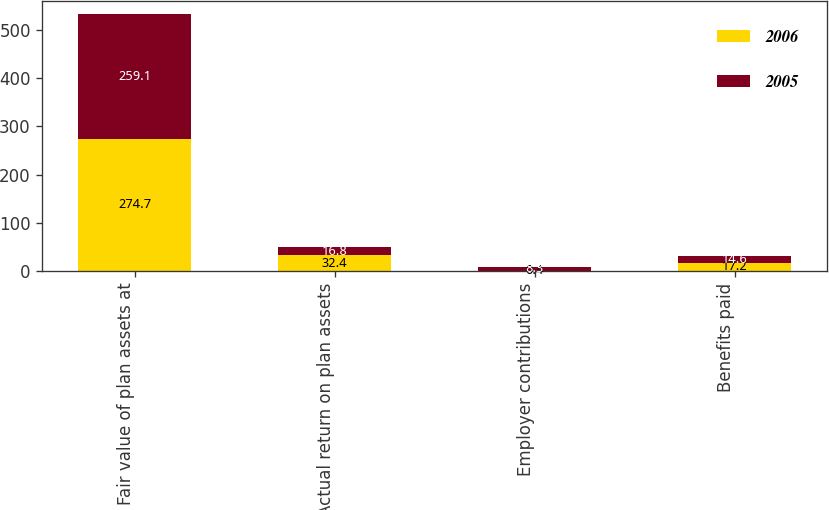Convert chart. <chart><loc_0><loc_0><loc_500><loc_500><stacked_bar_chart><ecel><fcel>Fair value of plan assets at<fcel>Actual return on plan assets<fcel>Employer contributions<fcel>Benefits paid<nl><fcel>2006<fcel>274.7<fcel>32.4<fcel>0.4<fcel>17.2<nl><fcel>2005<fcel>259.1<fcel>16.8<fcel>8.3<fcel>14.6<nl></chart> 